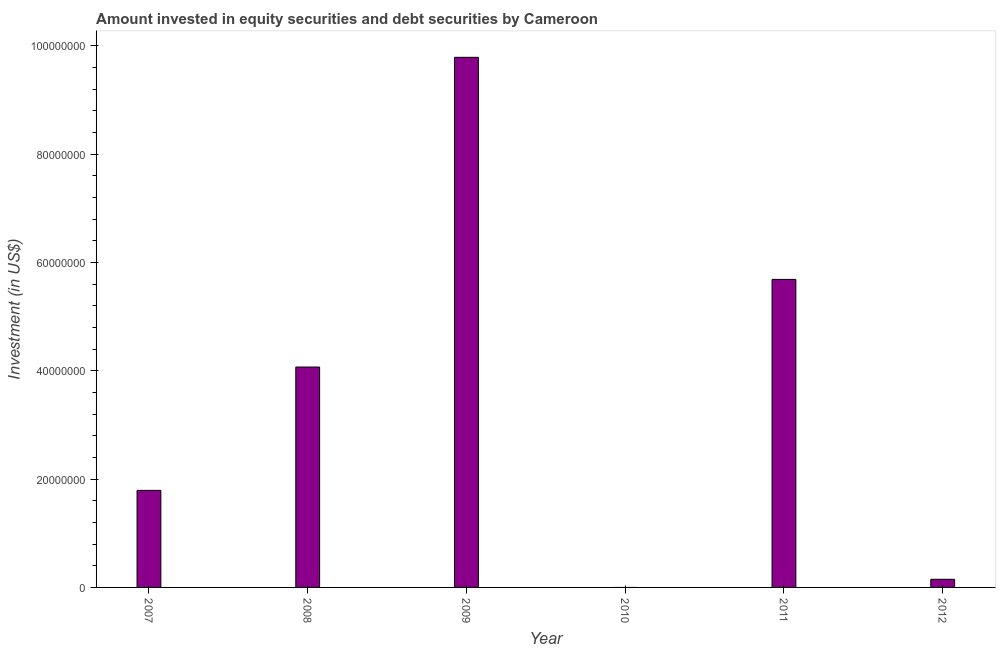Does the graph contain grids?
Keep it short and to the point. No. What is the title of the graph?
Your response must be concise. Amount invested in equity securities and debt securities by Cameroon. What is the label or title of the X-axis?
Your answer should be very brief. Year. What is the label or title of the Y-axis?
Ensure brevity in your answer.  Investment (in US$). What is the portfolio investment in 2007?
Give a very brief answer. 1.79e+07. Across all years, what is the maximum portfolio investment?
Offer a very short reply. 9.79e+07. In which year was the portfolio investment maximum?
Offer a very short reply. 2009. What is the sum of the portfolio investment?
Give a very brief answer. 2.15e+08. What is the difference between the portfolio investment in 2007 and 2012?
Provide a short and direct response. 1.64e+07. What is the average portfolio investment per year?
Your answer should be very brief. 3.58e+07. What is the median portfolio investment?
Offer a very short reply. 2.93e+07. In how many years, is the portfolio investment greater than 40000000 US$?
Offer a very short reply. 3. What is the ratio of the portfolio investment in 2009 to that in 2012?
Your answer should be compact. 65.15. Is the portfolio investment in 2007 less than that in 2012?
Give a very brief answer. No. Is the difference between the portfolio investment in 2007 and 2011 greater than the difference between any two years?
Provide a short and direct response. No. What is the difference between the highest and the second highest portfolio investment?
Offer a very short reply. 4.10e+07. What is the difference between the highest and the lowest portfolio investment?
Your response must be concise. 9.79e+07. In how many years, is the portfolio investment greater than the average portfolio investment taken over all years?
Provide a short and direct response. 3. What is the difference between two consecutive major ticks on the Y-axis?
Keep it short and to the point. 2.00e+07. Are the values on the major ticks of Y-axis written in scientific E-notation?
Make the answer very short. No. What is the Investment (in US$) in 2007?
Make the answer very short. 1.79e+07. What is the Investment (in US$) of 2008?
Your answer should be very brief. 4.07e+07. What is the Investment (in US$) in 2009?
Offer a terse response. 9.79e+07. What is the Investment (in US$) of 2011?
Ensure brevity in your answer.  5.69e+07. What is the Investment (in US$) of 2012?
Ensure brevity in your answer.  1.50e+06. What is the difference between the Investment (in US$) in 2007 and 2008?
Your answer should be very brief. -2.28e+07. What is the difference between the Investment (in US$) in 2007 and 2009?
Your response must be concise. -8.00e+07. What is the difference between the Investment (in US$) in 2007 and 2011?
Ensure brevity in your answer.  -3.90e+07. What is the difference between the Investment (in US$) in 2007 and 2012?
Your response must be concise. 1.64e+07. What is the difference between the Investment (in US$) in 2008 and 2009?
Make the answer very short. -5.72e+07. What is the difference between the Investment (in US$) in 2008 and 2011?
Keep it short and to the point. -1.62e+07. What is the difference between the Investment (in US$) in 2008 and 2012?
Offer a terse response. 3.92e+07. What is the difference between the Investment (in US$) in 2009 and 2011?
Your response must be concise. 4.10e+07. What is the difference between the Investment (in US$) in 2009 and 2012?
Keep it short and to the point. 9.64e+07. What is the difference between the Investment (in US$) in 2011 and 2012?
Offer a terse response. 5.54e+07. What is the ratio of the Investment (in US$) in 2007 to that in 2008?
Your response must be concise. 0.44. What is the ratio of the Investment (in US$) in 2007 to that in 2009?
Offer a very short reply. 0.18. What is the ratio of the Investment (in US$) in 2007 to that in 2011?
Provide a short and direct response. 0.32. What is the ratio of the Investment (in US$) in 2007 to that in 2012?
Your answer should be compact. 11.93. What is the ratio of the Investment (in US$) in 2008 to that in 2009?
Your answer should be compact. 0.42. What is the ratio of the Investment (in US$) in 2008 to that in 2011?
Offer a terse response. 0.71. What is the ratio of the Investment (in US$) in 2008 to that in 2012?
Your answer should be very brief. 27.09. What is the ratio of the Investment (in US$) in 2009 to that in 2011?
Provide a succinct answer. 1.72. What is the ratio of the Investment (in US$) in 2009 to that in 2012?
Keep it short and to the point. 65.15. What is the ratio of the Investment (in US$) in 2011 to that in 2012?
Offer a terse response. 37.86. 